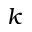<formula> <loc_0><loc_0><loc_500><loc_500>k</formula> 